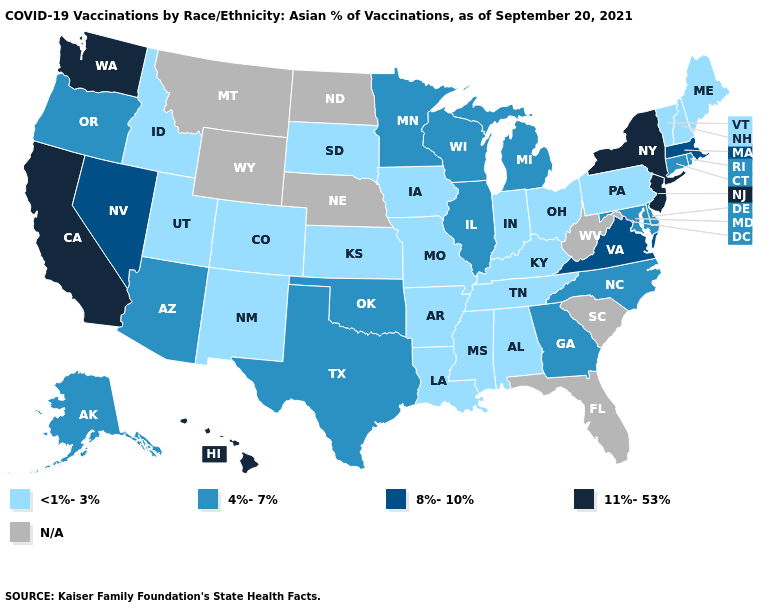Name the states that have a value in the range 11%-53%?
Concise answer only. California, Hawaii, New Jersey, New York, Washington. What is the value of Minnesota?
Concise answer only. 4%-7%. What is the lowest value in the MidWest?
Be succinct. <1%-3%. Name the states that have a value in the range 4%-7%?
Give a very brief answer. Alaska, Arizona, Connecticut, Delaware, Georgia, Illinois, Maryland, Michigan, Minnesota, North Carolina, Oklahoma, Oregon, Rhode Island, Texas, Wisconsin. Among the states that border Tennessee , does North Carolina have the lowest value?
Quick response, please. No. Name the states that have a value in the range <1%-3%?
Write a very short answer. Alabama, Arkansas, Colorado, Idaho, Indiana, Iowa, Kansas, Kentucky, Louisiana, Maine, Mississippi, Missouri, New Hampshire, New Mexico, Ohio, Pennsylvania, South Dakota, Tennessee, Utah, Vermont. Among the states that border Nevada , does Utah have the lowest value?
Be succinct. Yes. Which states have the lowest value in the South?
Write a very short answer. Alabama, Arkansas, Kentucky, Louisiana, Mississippi, Tennessee. Name the states that have a value in the range N/A?
Be succinct. Florida, Montana, Nebraska, North Dakota, South Carolina, West Virginia, Wyoming. What is the value of Michigan?
Be succinct. 4%-7%. What is the lowest value in the South?
Keep it brief. <1%-3%. Is the legend a continuous bar?
Keep it brief. No. Which states hav the highest value in the South?
Concise answer only. Virginia. What is the lowest value in the Northeast?
Be succinct. <1%-3%. 